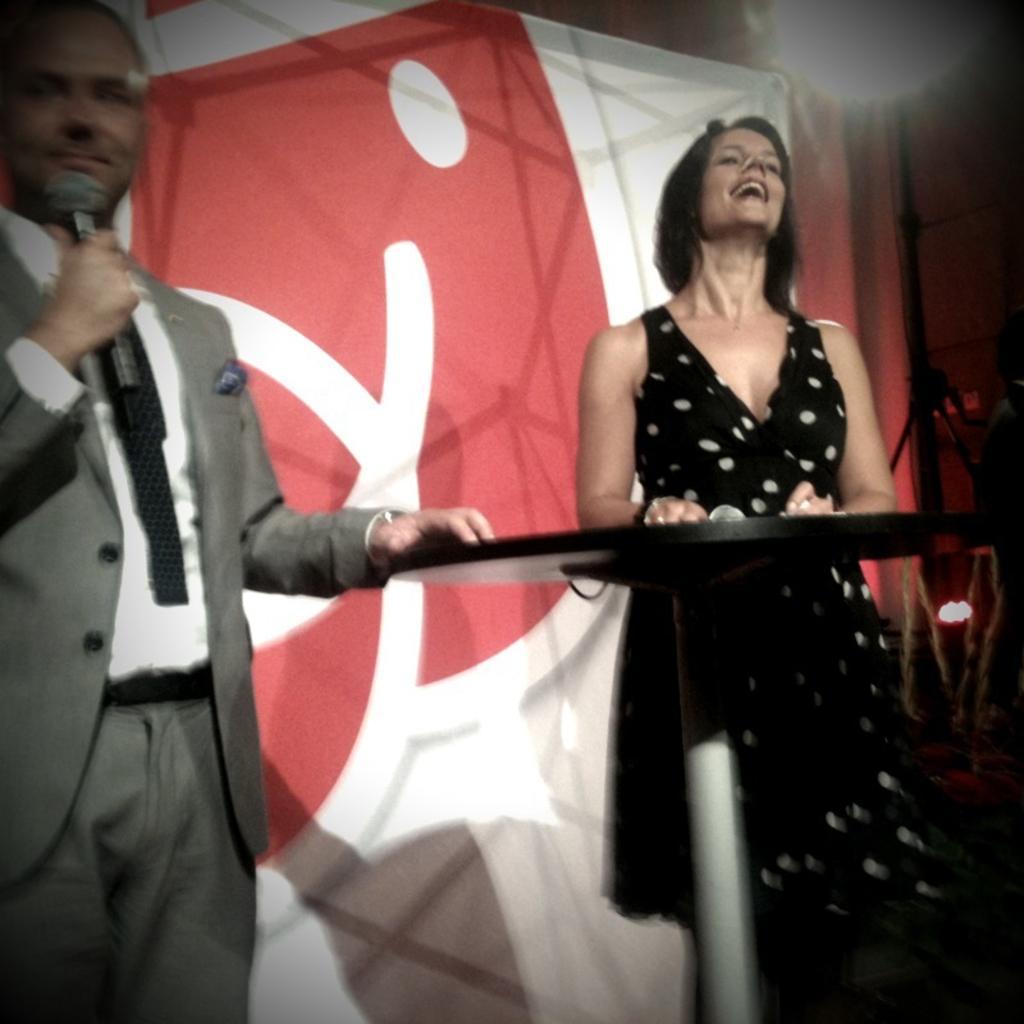Describe this image in one or two sentences. In this image, on the left side, we can see a man standing. He is holding a microphone, on the right side, we can see a woman standing and she is smiling, there is a table, in the background, we can see a poster. 